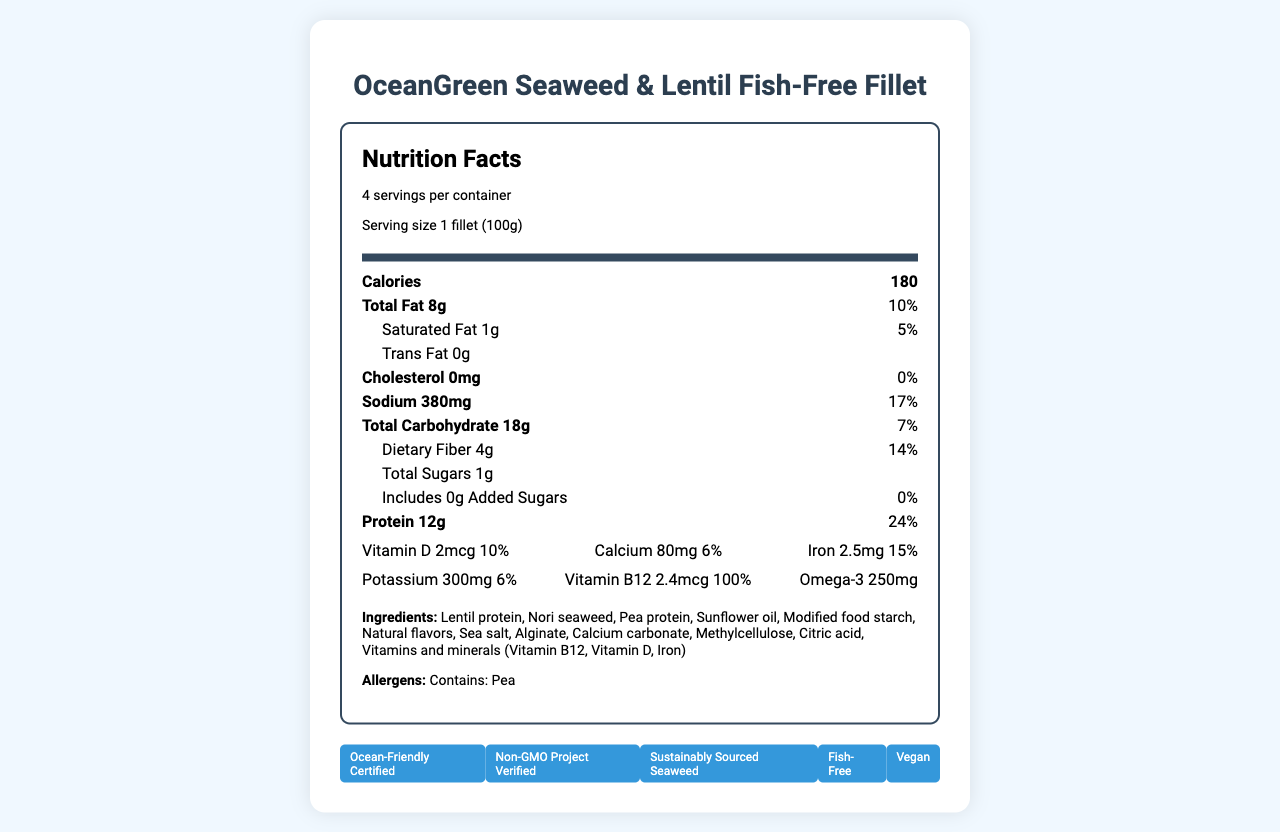how many servings are in the container? The document states that there are 4 servings per container.
Answer: 4 what is the serving size? The serving size is listed as "1 fillet (100g)".
Answer: 1 fillet (100g) how many calories are in one serving? The document indicates that there are 180 calories per serving.
Answer: 180 how much protein is in one serving of the product? The nutrition facts label shows that there are 12 grams of protein per serving.
Answer: 12g how much dietary fiber is in one serving? The dietary fiber content per serving is listed as 4 grams.
Answer: 4g how much total fat is in one serving? The nutrition facts label shows that there are 8 grams of total fat per serving.
Answer: 8g which nutrient has the highest daily value percentage? A. Sodium B. Dietary Fiber C. Protein D. Vitamin B12 Vitamin B12 has a daily value percentage of 100%, which is the highest among the listed nutrients.
Answer: D. Vitamin B12 which one of the following claims is NOT made by the product? A. Gluten-Free B. Ocean-Friendly Certified C. Non-GMO Project Verified The document does not mention a gluten-free claim, whereas it does include Ocean-Friendly Certified and Non-GMO Project Verified.
Answer: A. Gluten-Free is the product vegan? The product label includes an "ethical claims" section that states the product is vegan.
Answer: Yes does the product contain cholesterol? The nutrition label states that the cholesterol amount is 0 mg, which means it contains no cholesterol.
Answer: No is the product made with sustainably sourced ingredients? The product lists "Sustainably Sourced Seaweed" under ethical claims.
Answer: Yes what are the main ingredients of the OceanGreen Seaweed & Lentil Fish-Free Fillet? The ingredients are listed on the document, starting with Lentil protein and ending with Vitamins and minerals.
Answer: Lentil protein, Nori seaweed, Pea protein, Sunflower oil, Modified food starch, Natural flavors, Sea salt, Alginate, Calcium carbonate, Methylcellulose, Citric acid, Vitamins and minerals (Vitamin B12, Vitamin D, Iron) which vitamins and minerals are specifically added to the product? The document lists Vitamins and minerals, specifically Vitamin B12, Vitamin D, and Iron among the ingredients.
Answer: Vitamin B12, Vitamin D, Iron how much iron is in one serving, and what percentage of the daily value does it provide? One serving contains 2.5 mg of iron, which provides 15% of the daily value.
Answer: 2.5 mg, 15% what eco-friendly certifications does the product have? The certifications listed are Ocean-Friendly Certified and Non-GMO Project Verified.
Answer: Ocean-Friendly Certified, Non-GMO Project Verified does the product contain any added sugars? The label states that the total amount of added sugars is 0 g.
Answer: No are there any allergens listed for this product? The document lists "Pea" under the allergens section.
Answer: Yes, Pea what is the content of Omega-3 in the product? The nutrition label states that there are 250 mg of Omega-3 per serving.
Answer: 250 mg what is the most important ethical claim about the product? Among the ethical claims, "Fish-Free" directly relates to the primary nature of the plant-based seafood alternative.
Answer: Fish-Free describe the main idea of this document This document contains detailed nutritional information highlighting the product's health benefits and eco-friendly and ethical certifications, emphasizing the sustainable sourcing of ingredients.
Answer: The document provides the nutritional facts, ingredients, allergens, eco certifications, and ethical claims for OceanGreen Seaweed & Lentil Fish-Free Fillet. It's a plant-based seafood alternative that emphasizes sustainability and health, with significant nutrients like protein, dietary fiber, and Vitamin B12 while being free of cholesterol and added sugars. how is the product's sodium content compared to its daily value percentage? The product contains 380 mg of sodium, which is 17% of the daily value.
Answer: 380 mg, 17% is the product free of genetically modified organisms (GMOs)? The product is Non-GMO Project Verified according to the certifications listed.
Answer: Yes can the product help in getting the daily required amount of Vitamin B12? One serving of the product provides 100% of the daily value for Vitamin B12.
Answer: Yes what is the environmental impact of ocean-friendly certification? The specifics of the environmental impact of the Ocean-Friendly Certification are not detailed in the document.
Answer: I don't know 